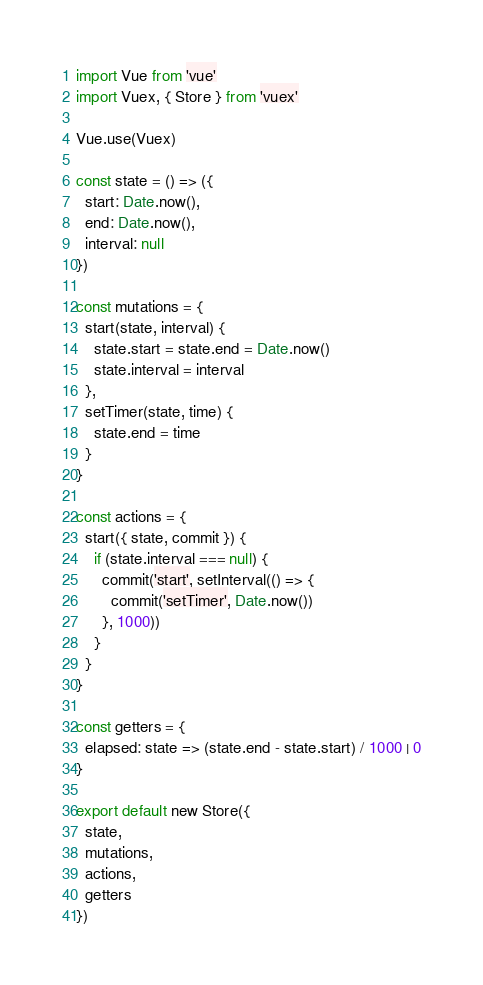Convert code to text. <code><loc_0><loc_0><loc_500><loc_500><_JavaScript_>import Vue from 'vue'
import Vuex, { Store } from 'vuex'

Vue.use(Vuex)

const state = () => ({
  start: Date.now(),
  end: Date.now(),
  interval: null
})

const mutations = {
  start(state, interval) {
    state.start = state.end = Date.now()
    state.interval = interval
  },
  setTimer(state, time) {
    state.end = time
  }
}

const actions = {
  start({ state, commit }) {
    if (state.interval === null) {
      commit('start', setInterval(() => {
        commit('setTimer', Date.now())
      }, 1000))
    }
  }
}

const getters = {
  elapsed: state => (state.end - state.start) / 1000 | 0
}

export default new Store({
  state,
  mutations,
  actions,
  getters
})

</code> 